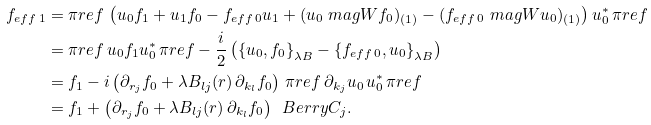<formula> <loc_0><loc_0><loc_500><loc_500>f _ { e f f \, 1 } & = \pi r e f \, \left ( u _ { 0 } f _ { 1 } + u _ { 1 } f _ { 0 } - f _ { e f f \, 0 } u _ { 1 } + ( u _ { 0 } \ m a g W f _ { 0 } ) _ { ( 1 ) } - ( f _ { e f f \, 0 } \ m a g W u _ { 0 } ) _ { ( 1 ) } \right ) u _ { 0 } ^ { * } \, \pi r e f \\ & = \pi r e f \, u _ { 0 } f _ { 1 } u _ { 0 } ^ { * } \, \pi r e f - \frac { i } { 2 } \left ( \left \{ u _ { 0 } , f _ { 0 } \right \} _ { \lambda B } - \left \{ f _ { e f f \, 0 } , u _ { 0 } \right \} _ { \lambda B } \right ) \\ & = f _ { 1 } - i \left ( \partial _ { r _ { j } } f _ { 0 } + \lambda B _ { l j } ( r ) \, \partial _ { k _ { l } } f _ { 0 } \right ) \, \pi r e f \, \partial _ { k _ { j } } u _ { 0 } \, u _ { 0 } ^ { * } \, \pi r e f \\ & = f _ { 1 } + \left ( \partial _ { r _ { j } } f _ { 0 } + \lambda B _ { l j } ( r ) \, \partial _ { k _ { l } } f _ { 0 } \right ) \, \ B e r r y C _ { j } .</formula> 